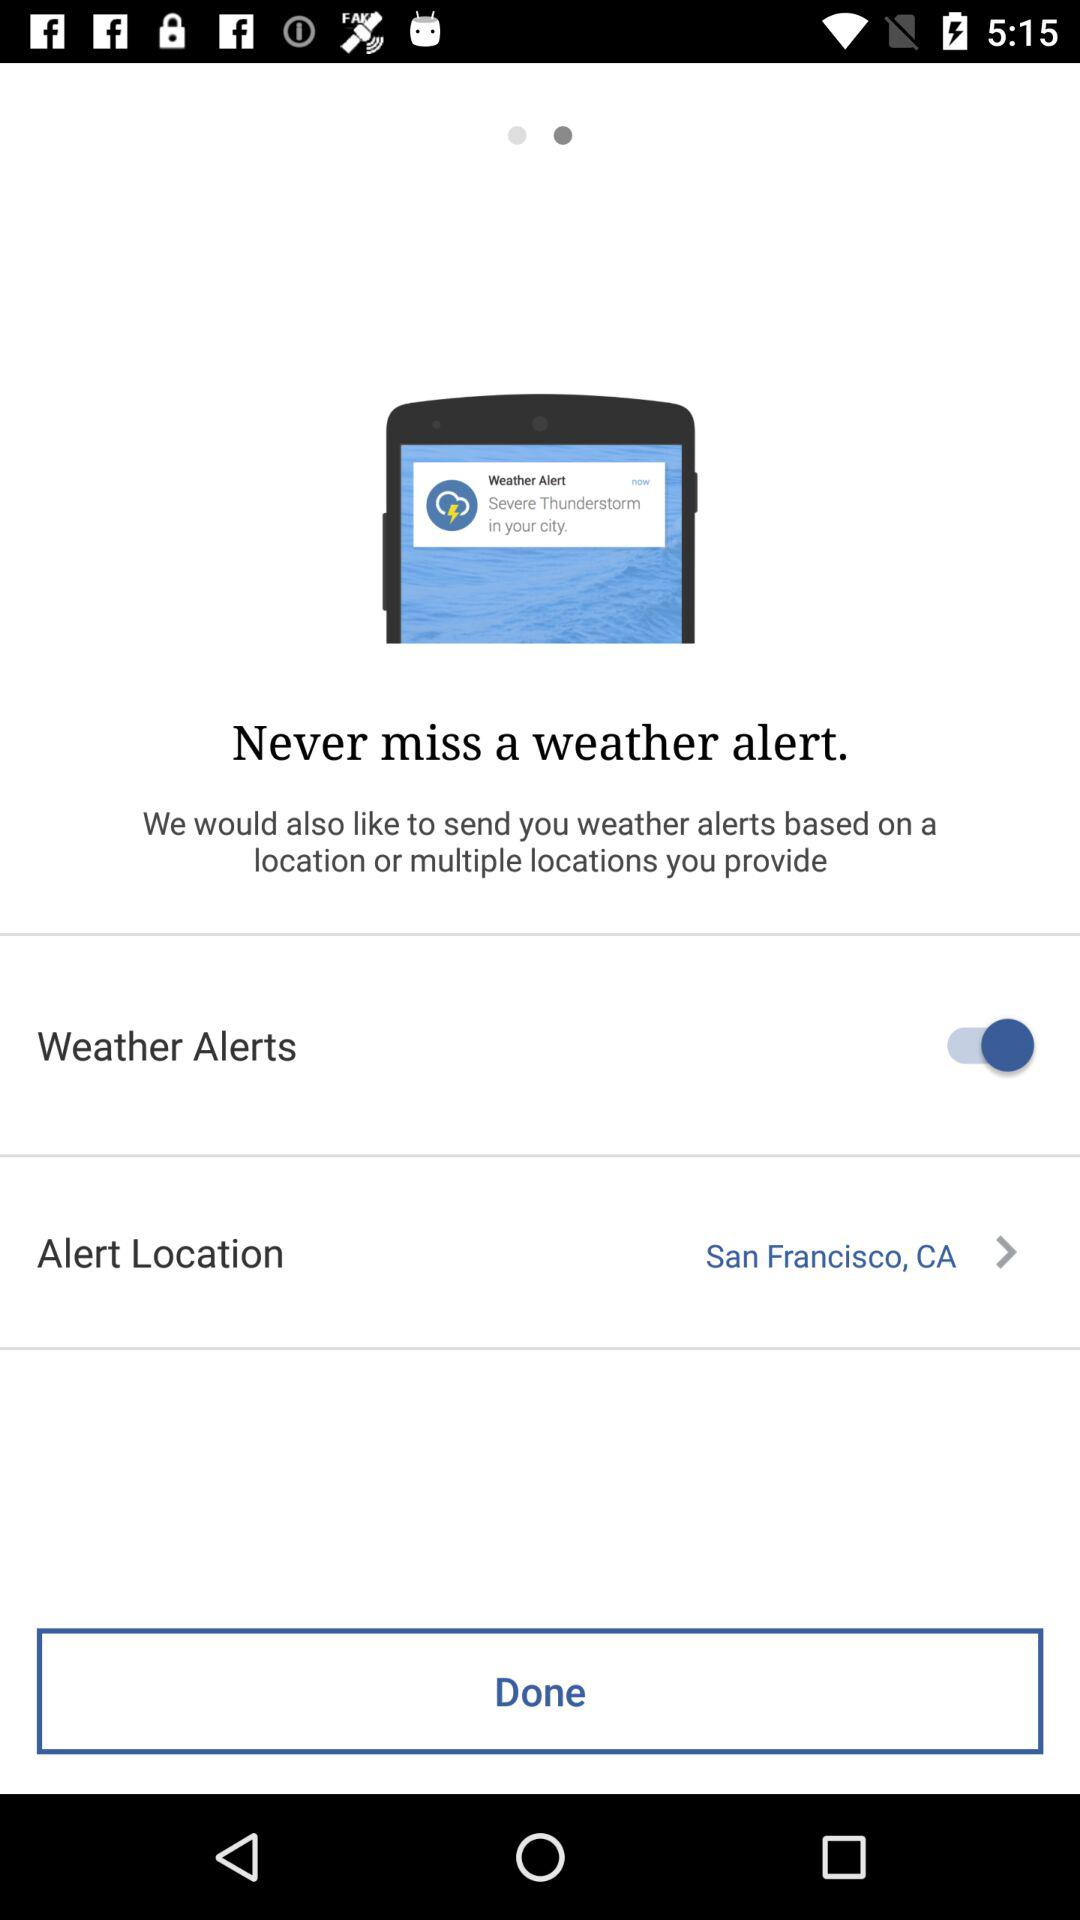What's the alert location? The alert location is San Francisco, CA. 